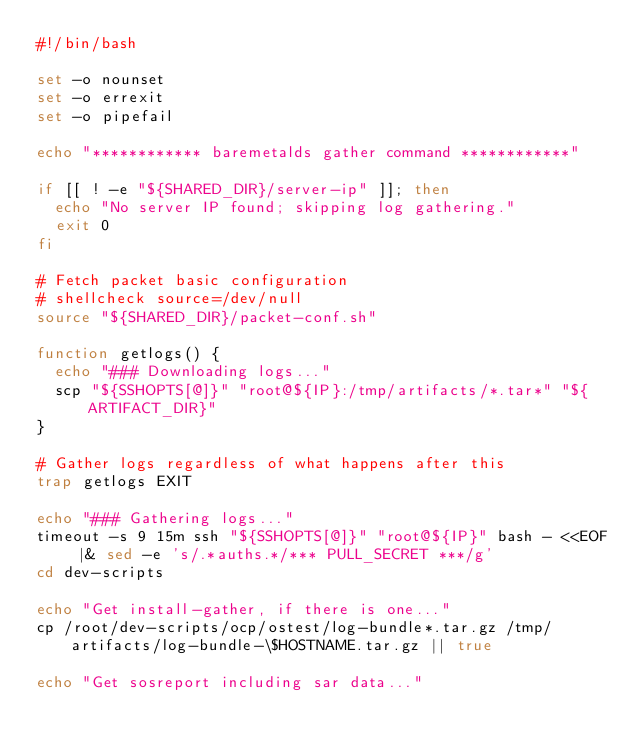Convert code to text. <code><loc_0><loc_0><loc_500><loc_500><_Bash_>#!/bin/bash

set -o nounset
set -o errexit
set -o pipefail

echo "************ baremetalds gather command ************"

if [[ ! -e "${SHARED_DIR}/server-ip" ]]; then
  echo "No server IP found; skipping log gathering."
  exit 0
fi

# Fetch packet basic configuration
# shellcheck source=/dev/null
source "${SHARED_DIR}/packet-conf.sh"

function getlogs() {
  echo "### Downloading logs..."
  scp "${SSHOPTS[@]}" "root@${IP}:/tmp/artifacts/*.tar*" "${ARTIFACT_DIR}"
}

# Gather logs regardless of what happens after this
trap getlogs EXIT

echo "### Gathering logs..."
timeout -s 9 15m ssh "${SSHOPTS[@]}" "root@${IP}" bash - <<EOF |& sed -e 's/.*auths.*/*** PULL_SECRET ***/g'
cd dev-scripts

echo "Get install-gather, if there is one..."
cp /root/dev-scripts/ocp/ostest/log-bundle*.tar.gz /tmp/artifacts/log-bundle-\$HOSTNAME.tar.gz || true

echo "Get sosreport including sar data..."</code> 